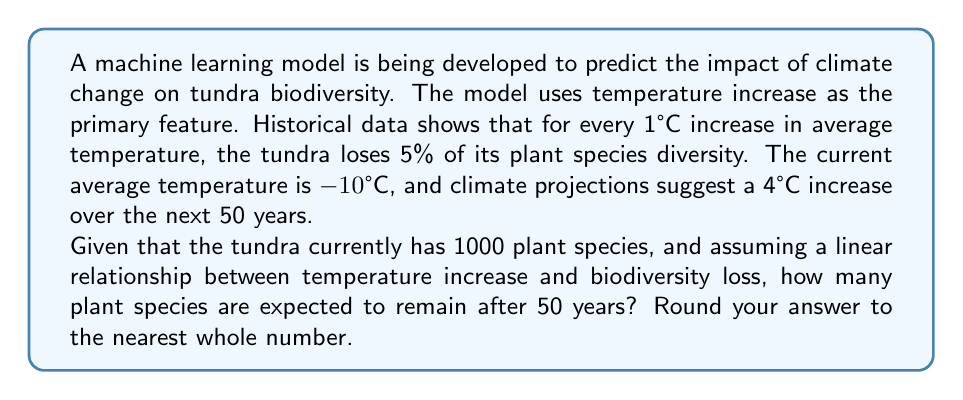Could you help me with this problem? Let's approach this problem step-by-step:

1) First, we need to determine the total temperature increase:
   $$\text{Temperature increase} = 4°C$$

2) We know that for every 1°C increase, 5% of plant species are lost. So for a 4°C increase:
   $$\text{Percentage loss} = 4 \times 5\% = 20\%$$

3) To calculate the number of species remaining, we need to subtract this percentage from the current number:
   $$\text{Remaining percentage} = 100\% - 20\% = 80\%$$

4) Now, we can calculate the number of remaining species:
   $$\text{Remaining species} = \text{Current species} \times \text{Remaining percentage}$$
   $$= 1000 \times 0.80 = 800$$

5) The question asks to round to the nearest whole number, but 800 is already a whole number, so no rounding is necessary.

This linear model assumes that the rate of species loss remains constant with temperature increase, which is a simplification. In reality, the relationship might be more complex, possibly following a logistic or exponential curve. More sophisticated machine learning models could potentially capture these non-linear relationships for more accurate predictions.
Answer: 800 plant species 